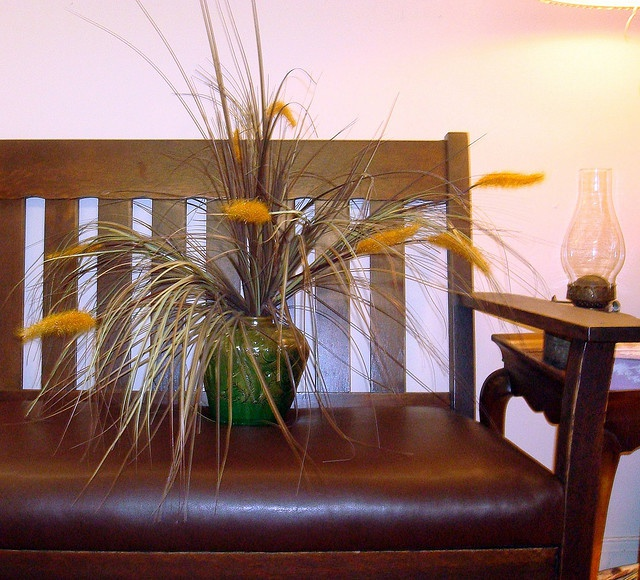Describe the objects in this image and their specific colors. I can see bench in lightgray, maroon, black, and gray tones, potted plant in lightgray, lavender, maroon, and gray tones, and vase in lightgray, black, olive, maroon, and darkgreen tones in this image. 